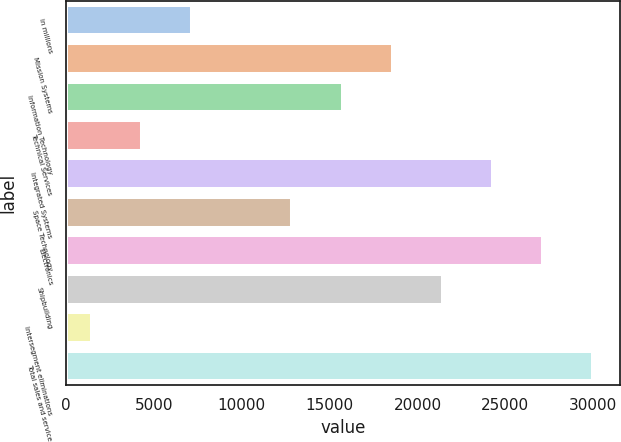Convert chart. <chart><loc_0><loc_0><loc_500><loc_500><bar_chart><fcel>in millions<fcel>Mission Systems<fcel>Information Technology<fcel>Technical Services<fcel>Integrated Systems<fcel>Space Technology<fcel>Electronics<fcel>Shipbuilding<fcel>Intersegment eliminations<fcel>Total sales and service<nl><fcel>7190.2<fcel>18590.6<fcel>15740.5<fcel>4340.1<fcel>24290.8<fcel>12890.4<fcel>27140.9<fcel>21440.7<fcel>1490<fcel>29991<nl></chart> 